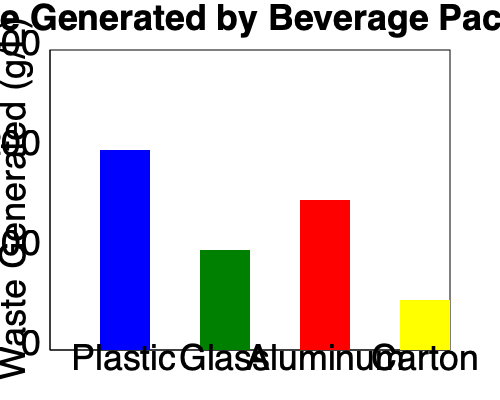As a marketing manager for a bottled water company, you're analyzing packaging options. Based on the graph, which packaging material generates the least plastic waste per liter, and how might this information influence your marketing strategy while addressing environmental concerns? To answer this question, we need to analyze the data presented in the bar graph and consider its implications for marketing strategy:

1. Interpret the graph:
   - The x-axis shows different packaging materials: Plastic, Glass, Aluminum, and Carton.
   - The y-axis represents waste generated in grams per liter (g/L).
   - The height of each bar indicates the amount of waste generated by each material.

2. Identify the material with the least waste:
   - Plastic: Approximately 200 g/L
   - Glass: Approximately 100 g/L
   - Aluminum: Approximately 150 g/L
   - Carton: Approximately 50 g/L
   - Carton packaging generates the least waste at about 50 g/L.

3. Marketing strategy considerations:
   a) Highlight environmental benefits:
      - Emphasize the lower waste generation of carton packaging in marketing campaigns.
      - Showcase the company's commitment to reducing plastic waste.

   b) Consumer education:
      - Inform customers about the environmental impact of different packaging types.
      - Explain how choosing carton-packaged water contributes to waste reduction.

   c) Brand positioning:
      - Position the brand as environmentally conscious and innovative.
      - Differentiate from competitors still using plastic bottles.

   d) Product development:
      - Consider transitioning to carton packaging for some or all product lines.
      - Explore ways to make carton packaging visually appealing and convenient.

   e) Addressing personal reservations:
      - Align marketing efforts with personal values by promoting a more sustainable option.
      - Use this as an opportunity to drive positive change in the industry.

4. Balancing marketing goals and environmental concerns:
   - Emphasize that choosing carton-packaged water allows consumers to enjoy bottled water while reducing their environmental impact.
   - Highlight any recycling or composting options for carton packaging.
   - Consider creating a campaign that encourages consumers to make small changes for significant environmental impact.

By focusing on carton packaging, the marketing strategy can effectively boost bottled water sales while addressing concerns about plastic waste, aligning with both business objectives and environmental responsibility.
Answer: Carton packaging; emphasize environmental benefits, educate consumers, and position the brand as eco-friendly. 